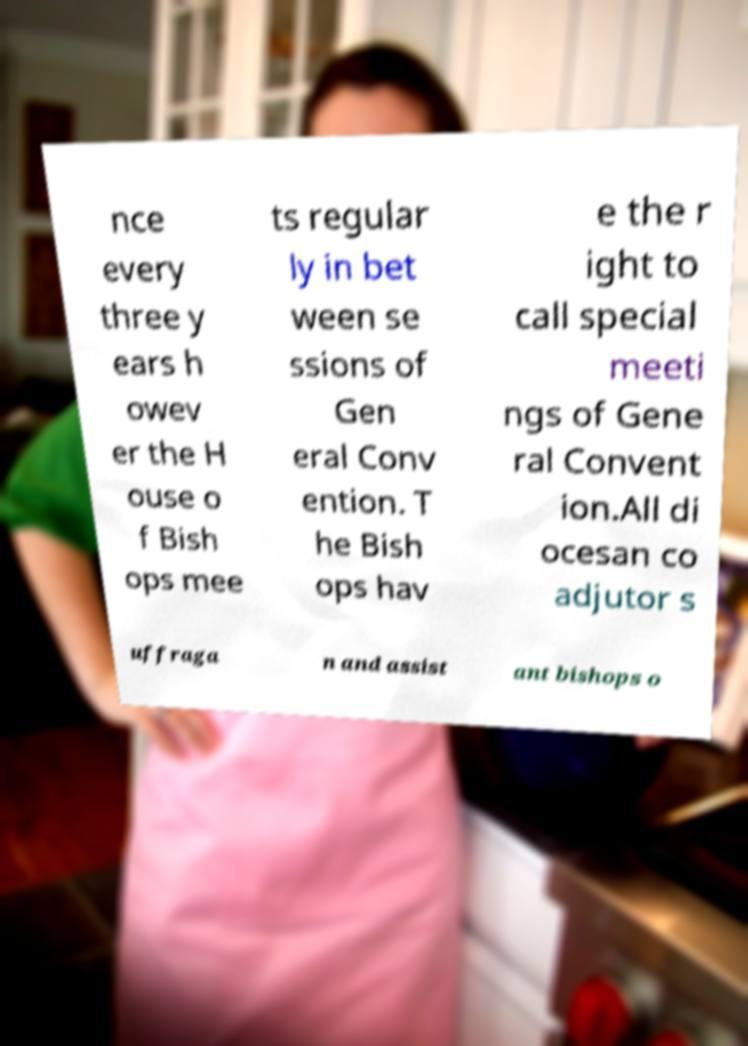Please identify and transcribe the text found in this image. nce every three y ears h owev er the H ouse o f Bish ops mee ts regular ly in bet ween se ssions of Gen eral Conv ention. T he Bish ops hav e the r ight to call special meeti ngs of Gene ral Convent ion.All di ocesan co adjutor s uffraga n and assist ant bishops o 